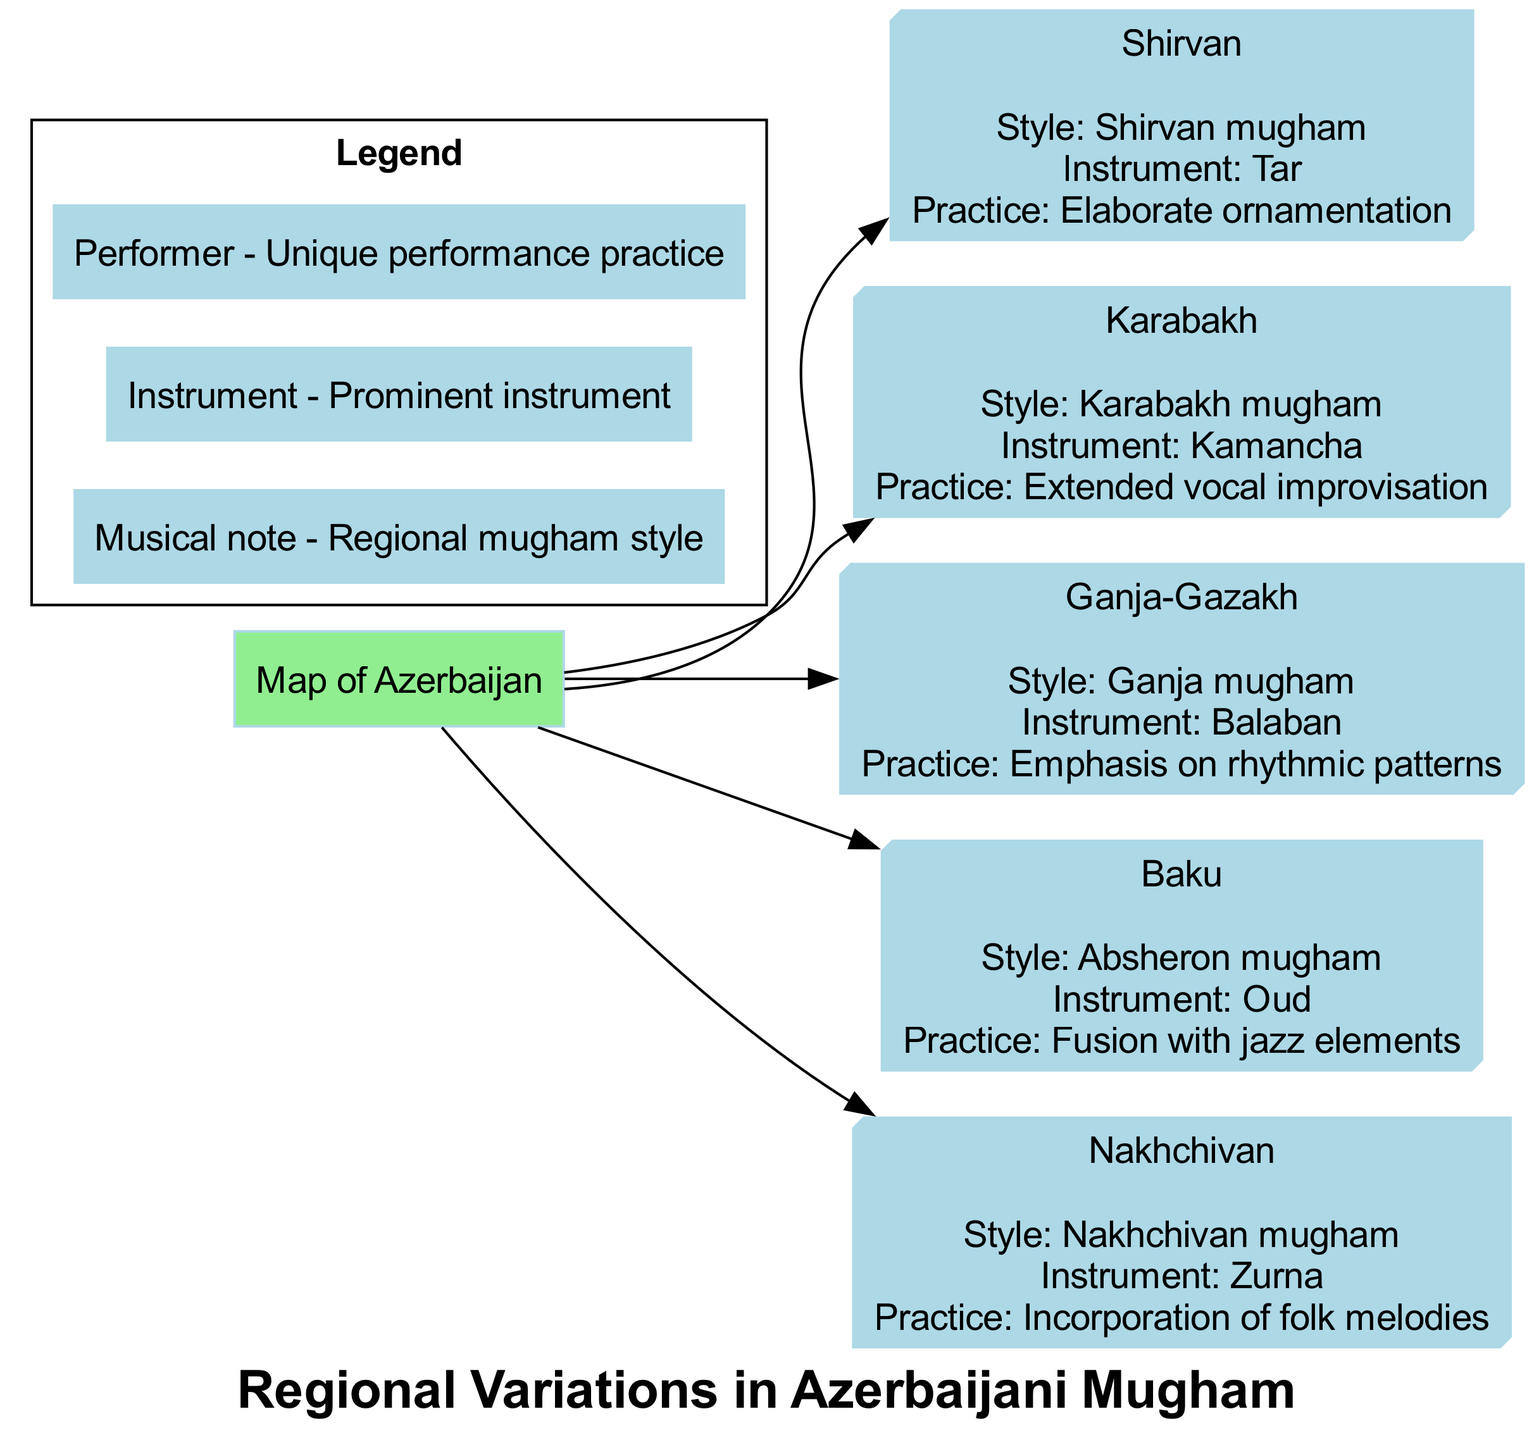What region is associated with "Elaborate ornamentation"? The diagram presents Shirvan as the region associated with the practice of "Elaborate ornamentation". This information can be found by looking at the specific details mentioned in the node for Shirvan.
Answer: Shirvan Which instrument is prominent in Baku? The node for Baku clearly states that the prominent instrument there is the Oud. This can be identified by reading the specific section of the Baku node.
Answer: Oud How many regions are highlighted in the diagram? The diagram lists five distinct regions: Shirvan, Karabakh, Ganja-Gazakh, Baku, and Nakhchivan. Counting these regions provides the total.
Answer: 5 What performance practice is emphasized in Ganja-Gazakh? Looking at the node for Ganja-Gazakh, it states that the emphasis is on "Emphasis on rhythmic patterns". This is directly provided in the node's information.
Answer: Emphasis on rhythmic patterns Which mugham style is linked to the kamancha? The diagram designates Karabakh mugham as the style linked to the kamancha. This can be determined from the Karabakh region's node.
Answer: Karabakh mugham Which region incorporates folk melodies in its performance practice? The nodal information for Nakhchivan specifies that it involves the "Incorporation of folk melodies" in its practice. Hence, Nakhchivan is the correct region.
Answer: Nakhchivan What type of fusion is found in Absheron mugham? The diagram indicates that Absheron mugham features a "Fusion with jazz elements". This information is specific to the Baku node where Absheron mugham is described.
Answer: Fusion with jazz elements What does the musical note icon signify in the legend? In the legend of the diagram, the musical note icon is labeled as indicating "Regional mugham style". This can be verified by examining the legend area of the diagram.
Answer: Regional mugham style 